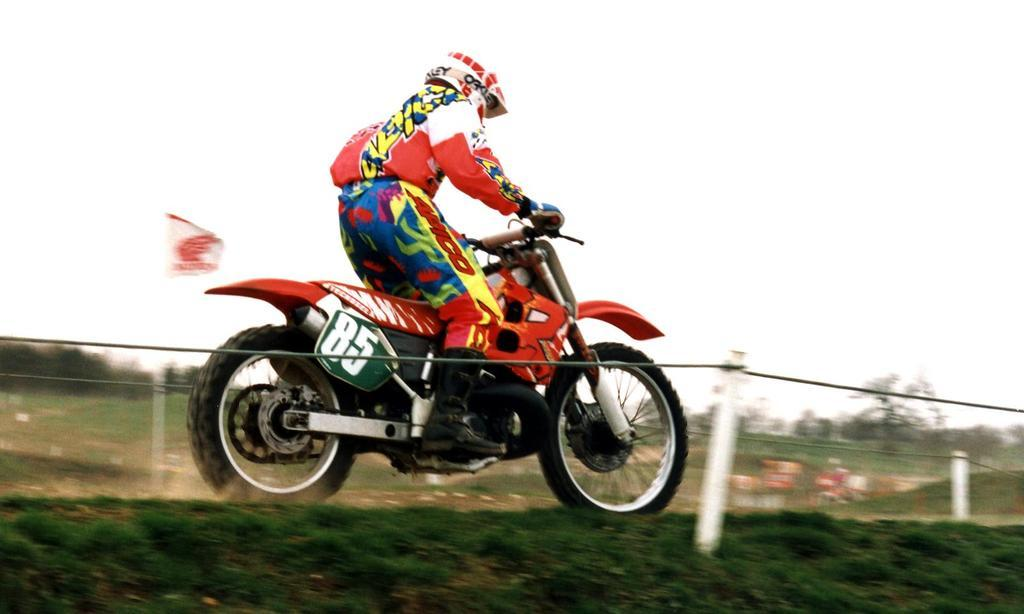What is the main subject of the image? There is a person riding a motorbike in the image. What else can be seen in the image besides the motorbike? There are poles, trees, grass, plants, wires, and the sky visible in the image. How many clocks are hanging on the poles in the image? There are no clocks visible in the image; only poles, trees, grass, plants, wires, and the sky can be seen. 